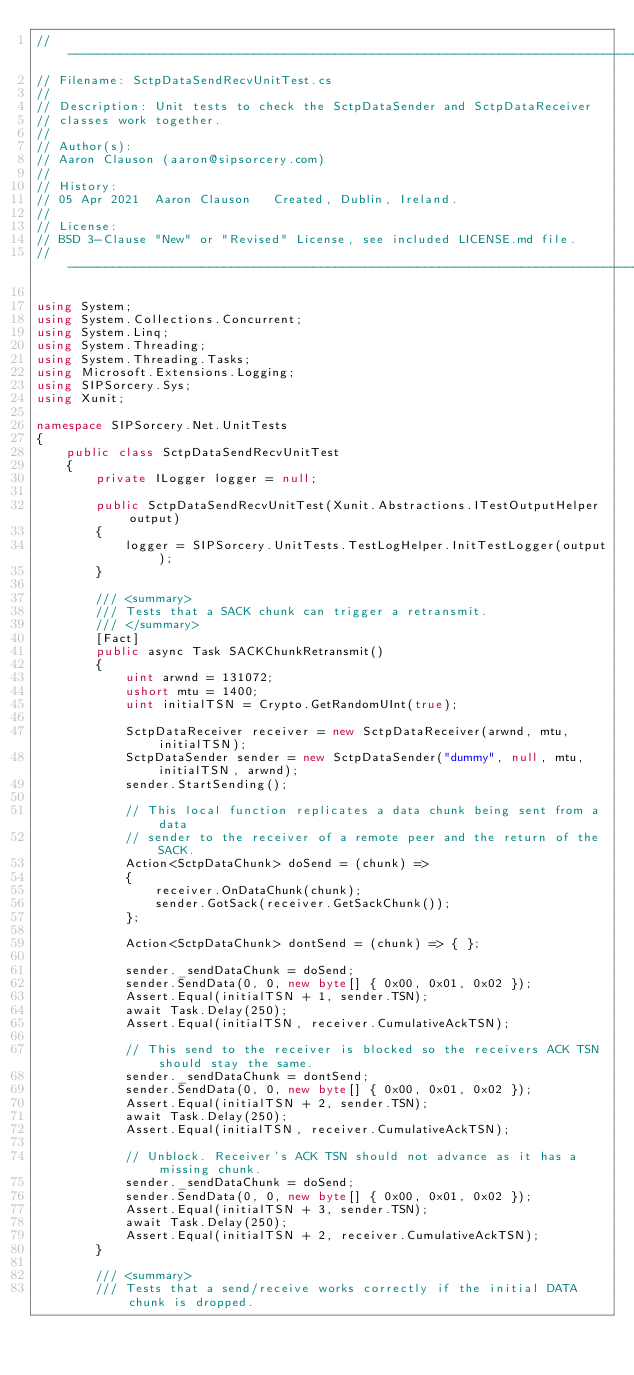Convert code to text. <code><loc_0><loc_0><loc_500><loc_500><_C#_>//-----------------------------------------------------------------------------
// Filename: SctpDataSendRecvUnitTest.cs
//
// Description: Unit tests to check the SctpDataSender and SctpDataReceiver
// classes work together.
//
// Author(s):
// Aaron Clauson (aaron@sipsorcery.com)
// 
// History:
// 05 Apr 2021	Aaron Clauson	Created, Dublin, Ireland.
//
// License: 
// BSD 3-Clause "New" or "Revised" License, see included LICENSE.md file.
//-----------------------------------------------------------------------------

using System;
using System.Collections.Concurrent;
using System.Linq;
using System.Threading;
using System.Threading.Tasks;
using Microsoft.Extensions.Logging;
using SIPSorcery.Sys;
using Xunit;

namespace SIPSorcery.Net.UnitTests
{
    public class SctpDataSendRecvUnitTest
    {
        private ILogger logger = null;

        public SctpDataSendRecvUnitTest(Xunit.Abstractions.ITestOutputHelper output)
        {
            logger = SIPSorcery.UnitTests.TestLogHelper.InitTestLogger(output);
        }

        /// <summary>
        /// Tests that a SACK chunk can trigger a retransmit.
        /// </summary>
        [Fact]
        public async Task SACKChunkRetransmit()
        {
            uint arwnd = 131072;
            ushort mtu = 1400;
            uint initialTSN = Crypto.GetRandomUInt(true);

            SctpDataReceiver receiver = new SctpDataReceiver(arwnd, mtu, initialTSN);
            SctpDataSender sender = new SctpDataSender("dummy", null, mtu, initialTSN, arwnd);
            sender.StartSending();

            // This local function replicates a data chunk being sent from a data
            // sender to the receiver of a remote peer and the return of the SACK. 
            Action<SctpDataChunk> doSend = (chunk) =>
            {
                receiver.OnDataChunk(chunk);
                sender.GotSack(receiver.GetSackChunk());
            };

            Action<SctpDataChunk> dontSend = (chunk) => { };

            sender._sendDataChunk = doSend;
            sender.SendData(0, 0, new byte[] { 0x00, 0x01, 0x02 });
            Assert.Equal(initialTSN + 1, sender.TSN);
            await Task.Delay(250);
            Assert.Equal(initialTSN, receiver.CumulativeAckTSN);

            // This send to the receiver is blocked so the receivers ACK TSN should stay the same.
            sender._sendDataChunk = dontSend;
            sender.SendData(0, 0, new byte[] { 0x00, 0x01, 0x02 });
            Assert.Equal(initialTSN + 2, sender.TSN);
            await Task.Delay(250);
            Assert.Equal(initialTSN, receiver.CumulativeAckTSN);

            // Unblock. Receiver's ACK TSN should not advance as it has a missing chunk.
            sender._sendDataChunk = doSend;
            sender.SendData(0, 0, new byte[] { 0x00, 0x01, 0x02 });
            Assert.Equal(initialTSN + 3, sender.TSN);
            await Task.Delay(250);
            Assert.Equal(initialTSN + 2, receiver.CumulativeAckTSN);
        }

        /// <summary>
        /// Tests that a send/receive works correctly if the initial DATA chunk is dropped.</code> 